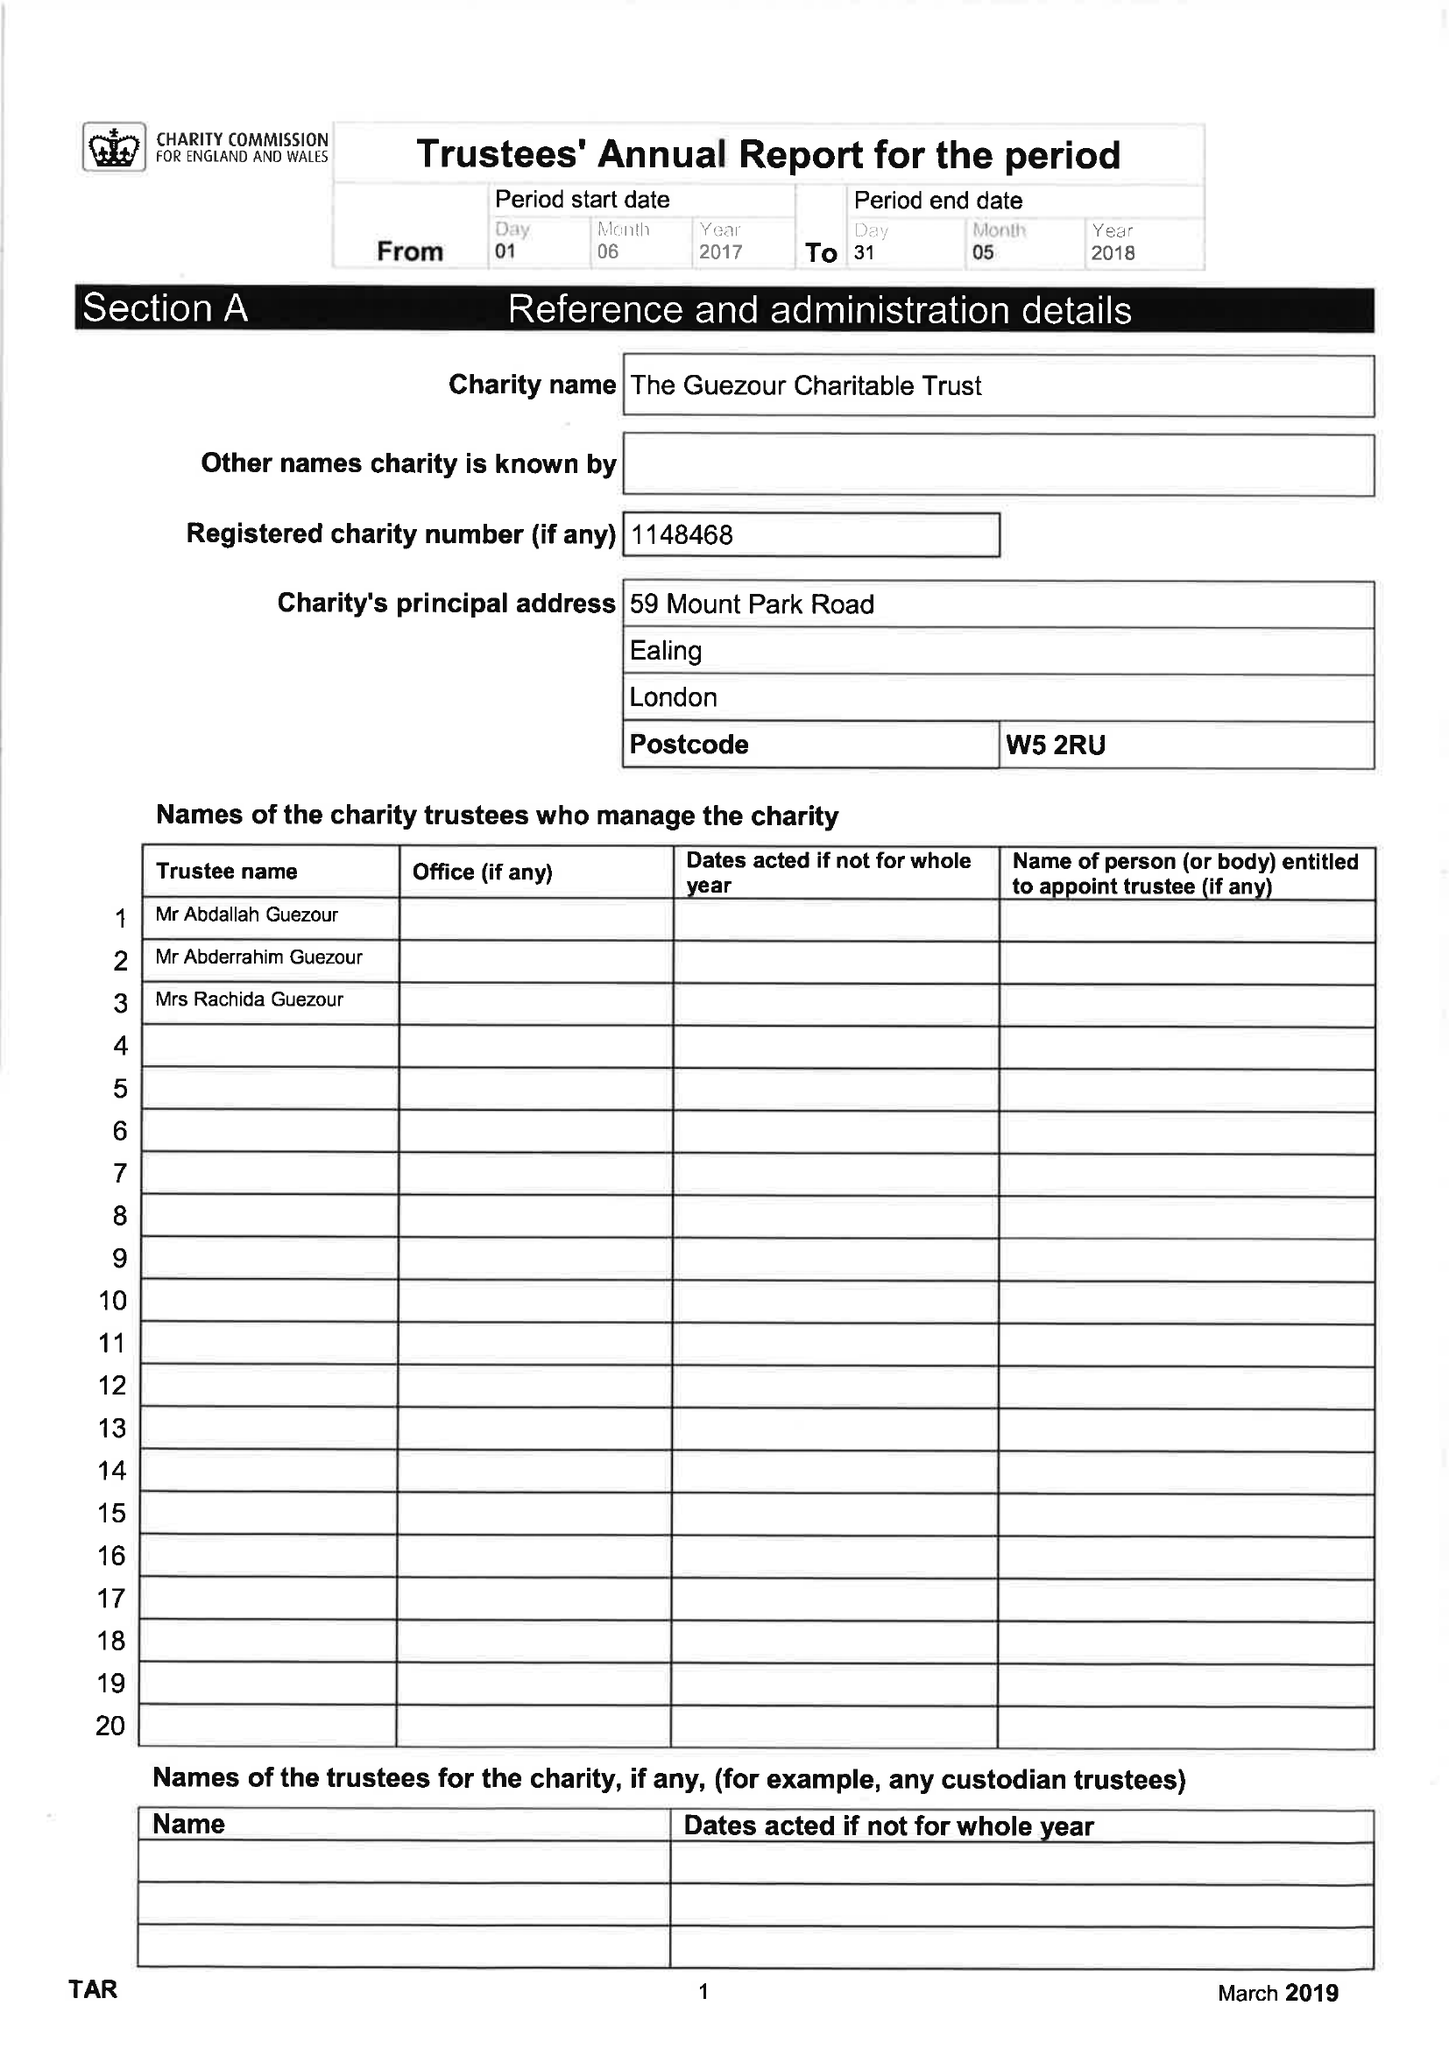What is the value for the address__postcode?
Answer the question using a single word or phrase. W5 2RU 